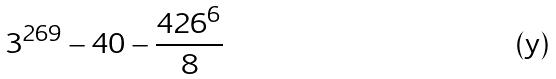<formula> <loc_0><loc_0><loc_500><loc_500>3 ^ { 2 6 9 } - 4 0 - \frac { 4 2 6 ^ { 6 } } { 8 }</formula> 